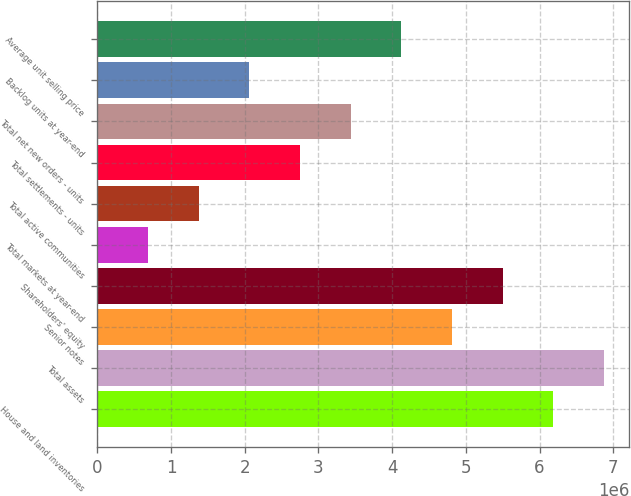Convert chart. <chart><loc_0><loc_0><loc_500><loc_500><bar_chart><fcel>House and land inventories<fcel>Total assets<fcel>Senior notes<fcel>Shareholders' equity<fcel>Total markets at year-end<fcel>Total active communities<fcel>Total settlements - units<fcel>Total net new orders - units<fcel>Backlog units at year-end<fcel>Average unit selling price<nl><fcel>6.18488e+06<fcel>6.87209e+06<fcel>4.81047e+06<fcel>5.49767e+06<fcel>687226<fcel>1.37443e+06<fcel>2.74885e+06<fcel>3.43605e+06<fcel>2.06164e+06<fcel>4.12326e+06<nl></chart> 